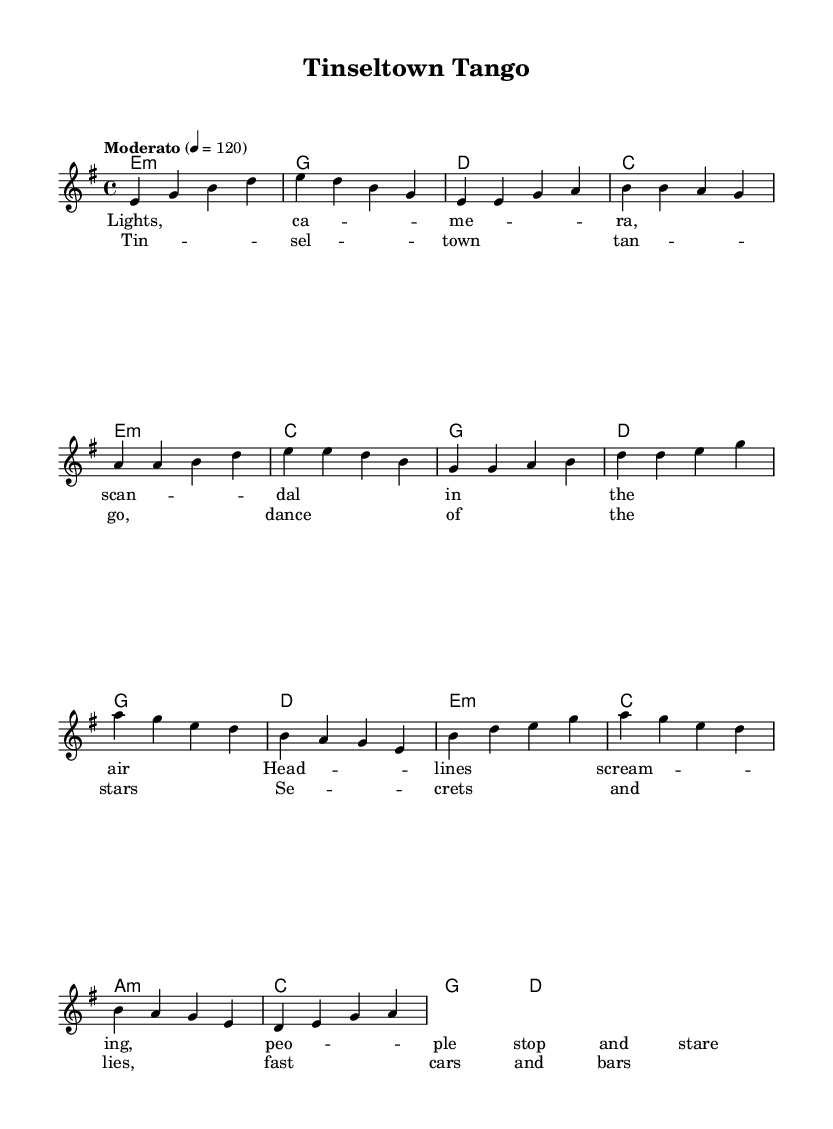What is the key signature of this music? The key signature is E minor, indicated by the presence of one sharp (F#) that typically represents the key. This can be determined from the global section of the code which states "\key e \minor".
Answer: E minor What is the time signature of this music? The time signature is 4/4, as indicated in the global section of the code with "\time 4/4". This means there are four beats per measure, and the quarter note gets one beat.
Answer: 4/4 What is the tempo marking given for the piece? The tempo marking given is "Moderato", which typically means moderate speed. This is indicated in the global section where it states "\tempo 'Moderato' 4 = 120".
Answer: Moderato How many measures are in the chorus section? The chorus consists of four measures, which can be counted by identifying the individual measures grouped together in the chord and melody sections of the score under the chorus lyrics.
Answer: 4 What is the lyric theme of the song as indicated in the verses? The themes presented in the verses revolve around fame and public attention, as seen in the lyrics mentioning "Lights, camera, scandal" and "Headlines screaming". The structure of the lyrics suggests a story that reflects on the celebrity culture.
Answer: Fame and scandal What kind of musical form does this song follow? This song follows a verse-chorus structure, evident from the distinct sections labeled "Verse" and "Chorus" in the provided code, showing a pattern of alternating between these two sections.
Answer: Verse-Chorus What type of chords are used in the bridge of the song? The bridge utilizes minor chords like A minor, which can be identified in the chord section with "a1:m" and the progression that includes other major and minor chords, creating a contrasting section.
Answer: Minor chords 